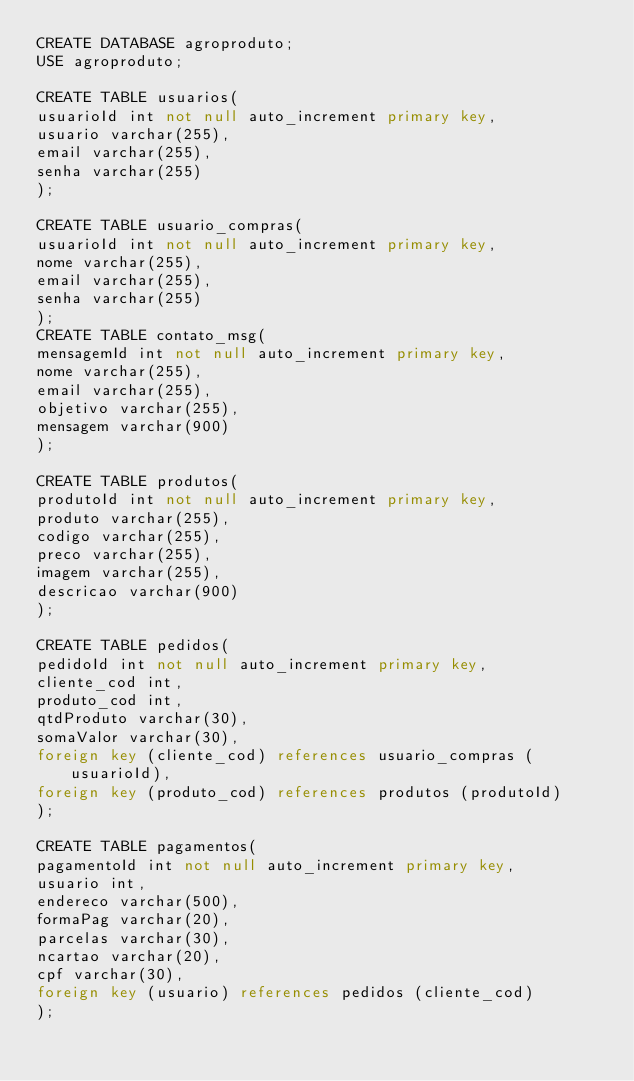Convert code to text. <code><loc_0><loc_0><loc_500><loc_500><_SQL_>CREATE DATABASE agroproduto;
USE agroproduto;

CREATE TABLE usuarios(
usuarioId int not null auto_increment primary key,
usuario varchar(255),
email varchar(255),
senha varchar(255)
);

CREATE TABLE usuario_compras(
usuarioId int not null auto_increment primary key,
nome varchar(255),
email varchar(255),
senha varchar(255)
);
CREATE TABLE contato_msg(
mensagemId int not null auto_increment primary key,
nome varchar(255),
email varchar(255),
objetivo varchar(255),
mensagem varchar(900)
);

CREATE TABLE produtos(
produtoId int not null auto_increment primary key,
produto varchar(255),
codigo varchar(255),
preco varchar(255),
imagem varchar(255),
descricao varchar(900)
);

CREATE TABLE pedidos(
pedidoId int not null auto_increment primary key,
cliente_cod int,
produto_cod int,
qtdProduto varchar(30),
somaValor varchar(30),
foreign key (cliente_cod) references usuario_compras (usuarioId),
foreign key (produto_cod) references produtos (produtoId)
);

CREATE TABLE pagamentos(
pagamentoId int not null auto_increment primary key,
usuario int,
endereco varchar(500),
formaPag varchar(20),
parcelas varchar(30),
ncartao varchar(20),
cpf varchar(30),
foreign key (usuario) references pedidos (cliente_cod)
);
</code> 